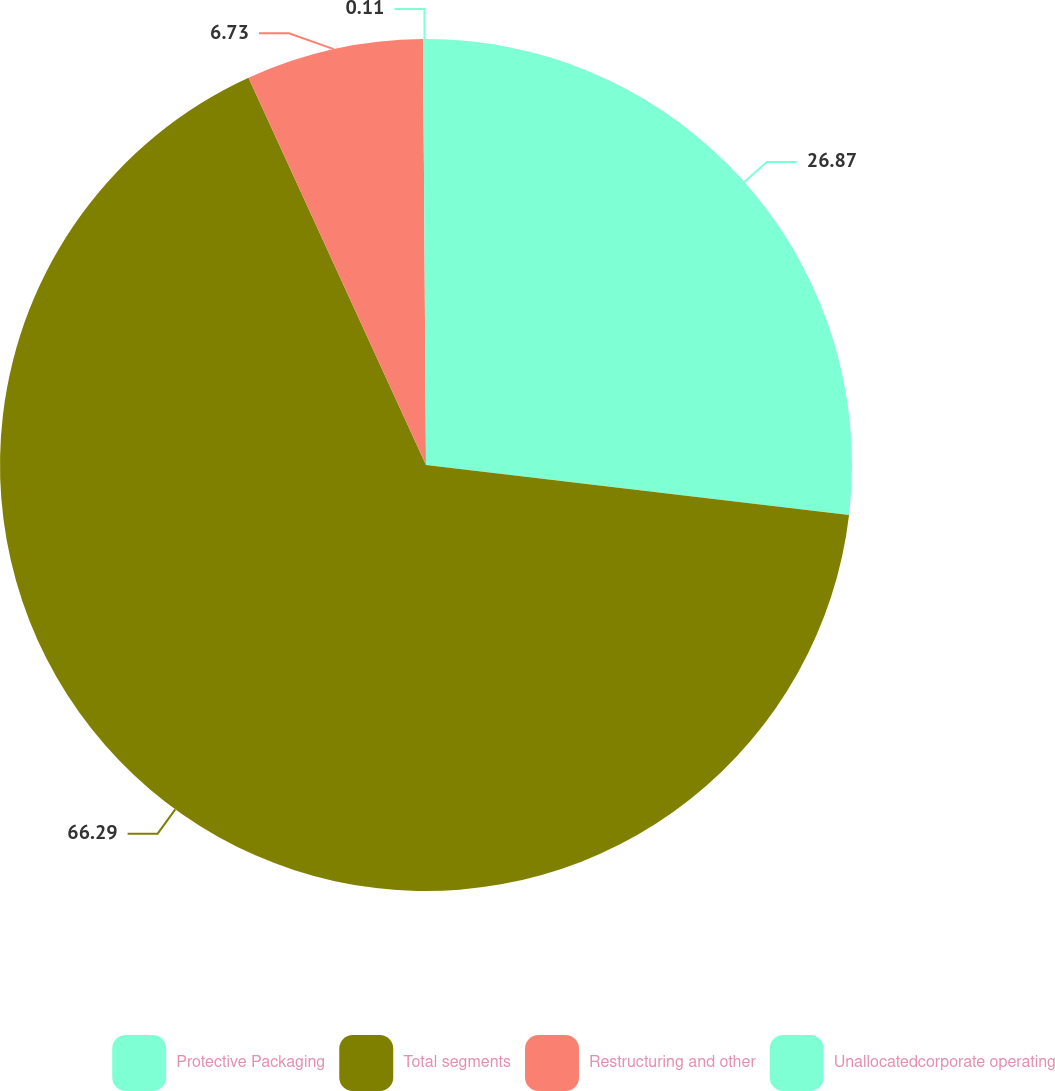Convert chart to OTSL. <chart><loc_0><loc_0><loc_500><loc_500><pie_chart><fcel>Protective Packaging<fcel>Total segments<fcel>Restructuring and other<fcel>Unallocatedcorporate operating<nl><fcel>26.87%<fcel>66.29%<fcel>6.73%<fcel>0.11%<nl></chart> 